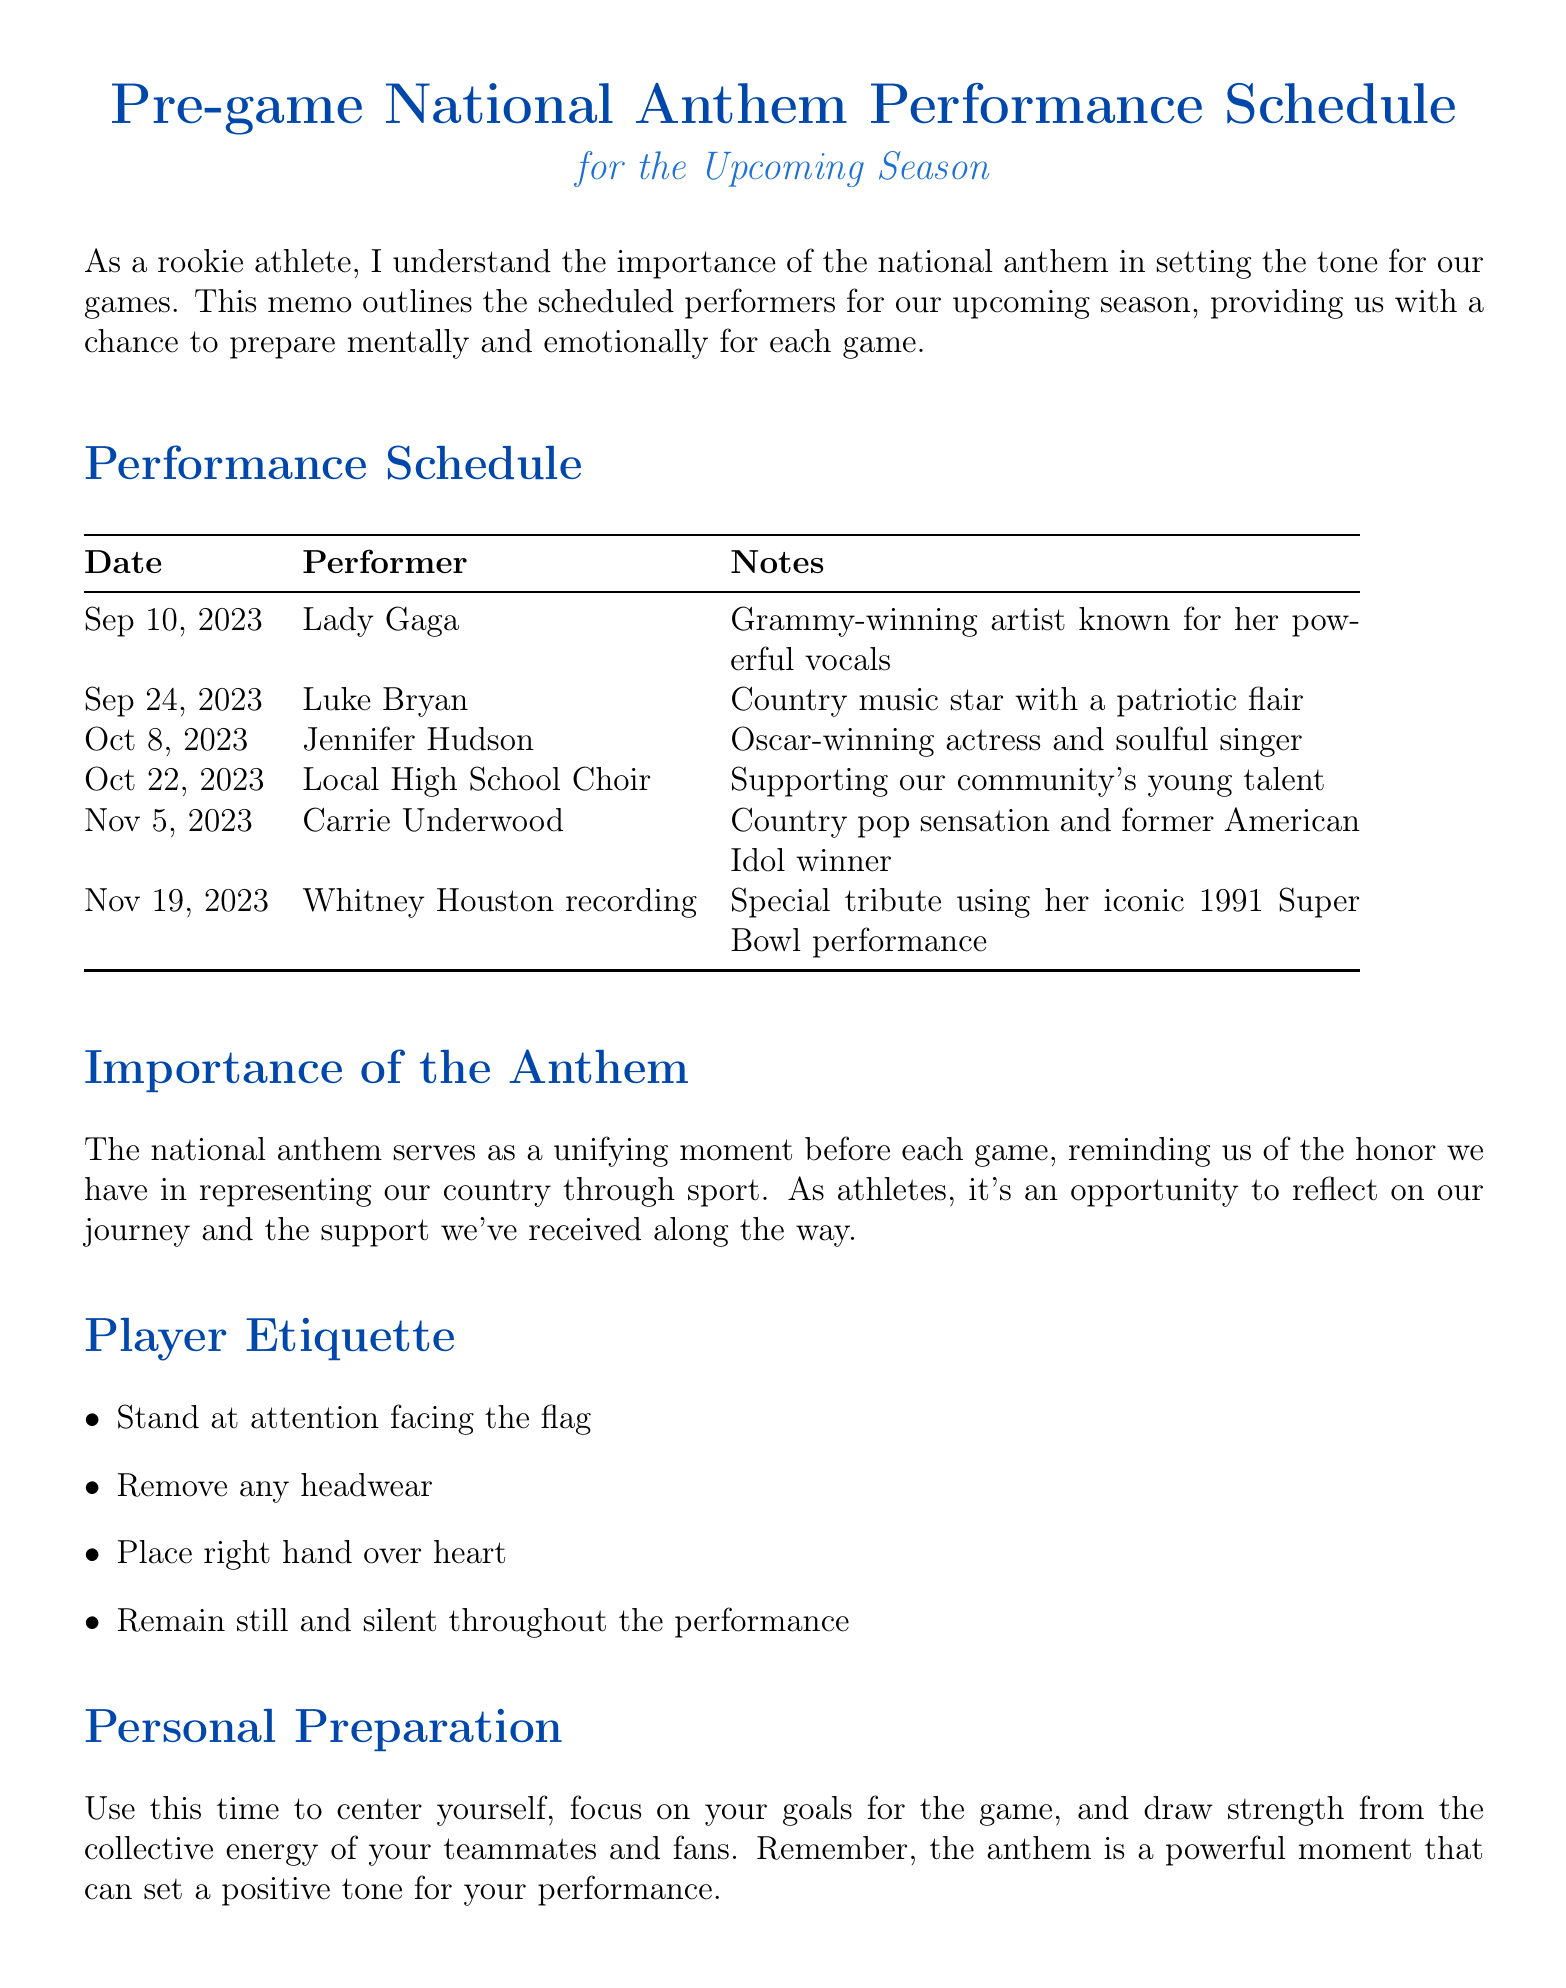What is the title of the memo? The title is found at the top of the document, summarizing the main topic addressed in it.
Answer: Pre-game National Anthem Performance Schedule for the Upcoming Season Who is scheduled to perform on November 19, 2023? This information is located in the performance schedule section detailing who will perform on specific dates.
Answer: Whitney Houston recording What is the duration of the national anthem? This is mentioned in the additional information section regarding key facts about the anthem performance.
Answer: Approximately 1 minute and 30 seconds What special event is noted for November 11, 2023? The document lists significant events that coincide with anthem performances, highlighting one specific event's detail.
Answer: Veterans Day What should players do with their headwear during the anthem? Player etiquette is outlined in a dedicated section, specifying proper conduct during the performance.
Answer: Remove any headwear Why is the national anthem important for athletes? The importance section discusses the anthem's role to inspire athletes, reflecting on their experience and culture of sport.
Answer: A unifying moment When is the Christmas Day game? This detail can be found under the additional information section where special events are mentioned with specific dates.
Answer: December 25, 2023 Who is performing on October 22, 2023? The performance schedule clearly lists the performers for each game date, including that specific date's performer.
Answer: Local High School Choir 